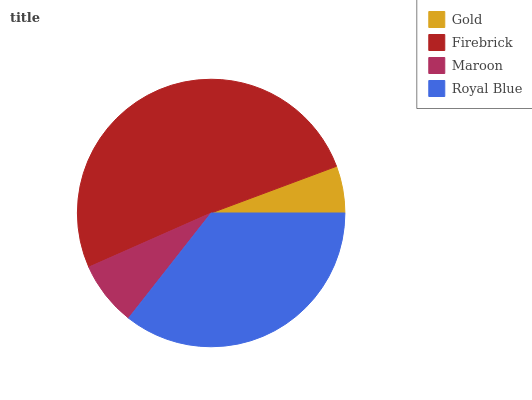Is Gold the minimum?
Answer yes or no. Yes. Is Firebrick the maximum?
Answer yes or no. Yes. Is Maroon the minimum?
Answer yes or no. No. Is Maroon the maximum?
Answer yes or no. No. Is Firebrick greater than Maroon?
Answer yes or no. Yes. Is Maroon less than Firebrick?
Answer yes or no. Yes. Is Maroon greater than Firebrick?
Answer yes or no. No. Is Firebrick less than Maroon?
Answer yes or no. No. Is Royal Blue the high median?
Answer yes or no. Yes. Is Maroon the low median?
Answer yes or no. Yes. Is Gold the high median?
Answer yes or no. No. Is Firebrick the low median?
Answer yes or no. No. 